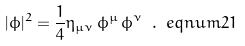<formula> <loc_0><loc_0><loc_500><loc_500>| \phi | ^ { 2 } = \frac { 1 } { 4 } \eta _ { \mu \nu } \, \phi ^ { \mu } \, \phi ^ { \nu } \ . \ e q n u m { 2 1 }</formula> 